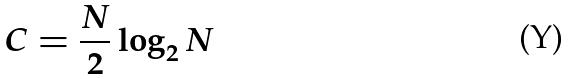Convert formula to latex. <formula><loc_0><loc_0><loc_500><loc_500>C = \frac { N } { 2 } \log _ { 2 } N</formula> 